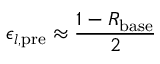<formula> <loc_0><loc_0><loc_500><loc_500>\epsilon _ { l , p r e } \approx \frac { 1 - R _ { b a s e } } { 2 }</formula> 